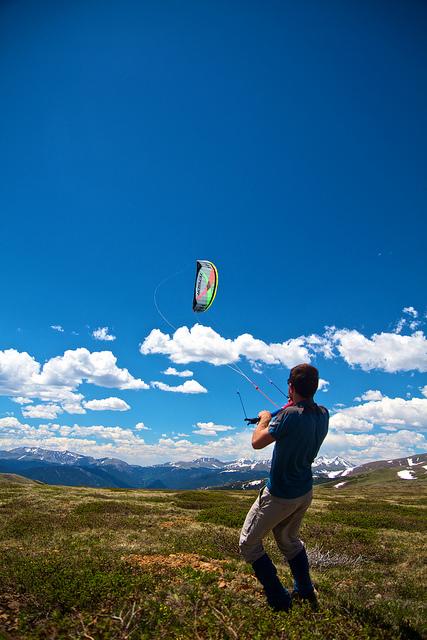How many kites is this person flying?
Write a very short answer. 1. Are there clouds in the sky?
Concise answer only. Yes. How many kites are in the sky?
Quick response, please. 1. 